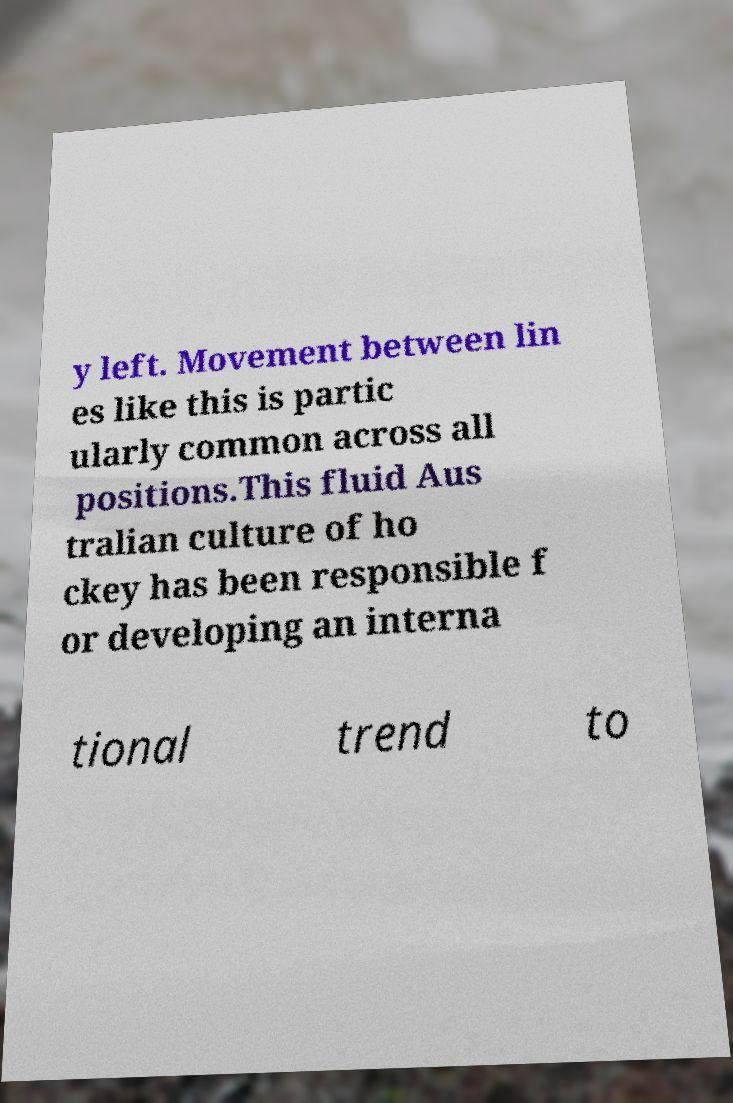There's text embedded in this image that I need extracted. Can you transcribe it verbatim? y left. Movement between lin es like this is partic ularly common across all positions.This fluid Aus tralian culture of ho ckey has been responsible f or developing an interna tional trend to 